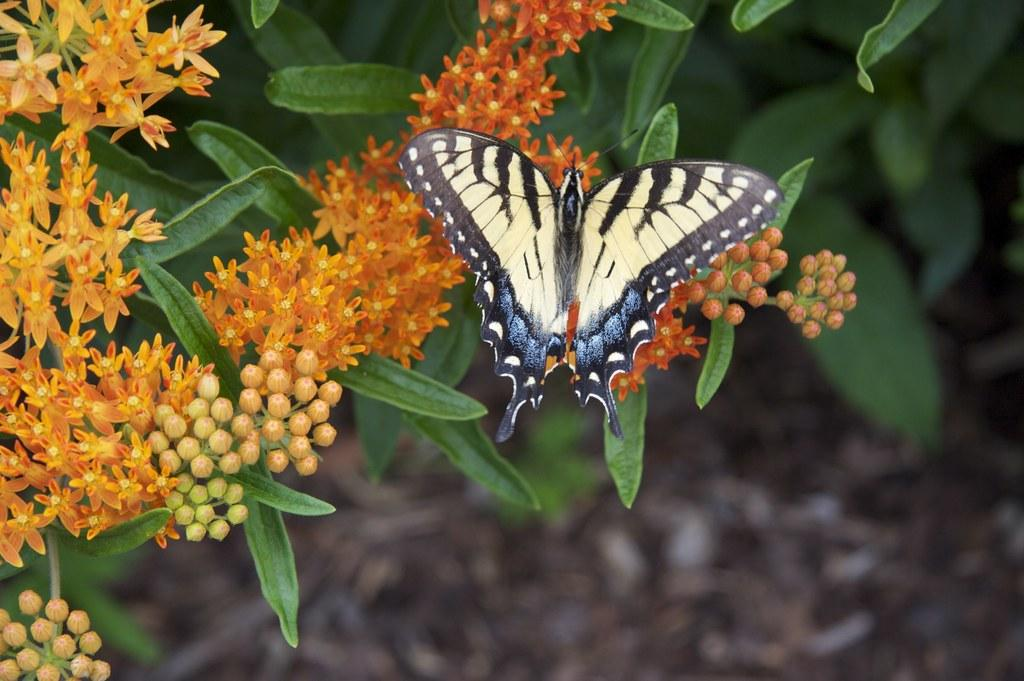What is the main subject of the image? There is a butterfly in the image. Can you describe the colors of the butterfly? The butterfly has cream and black colors. What is the butterfly resting on? The butterfly is on orange color flowers. What type of vegetation is present in the image? There are green leaves in the image. How would you describe the background of the image? The background of the image is blurred. Can you tell me how many strangers are visible in the image? There are no strangers present in the image; it features a butterfly on orange flowers with green leaves and a blurred background. 